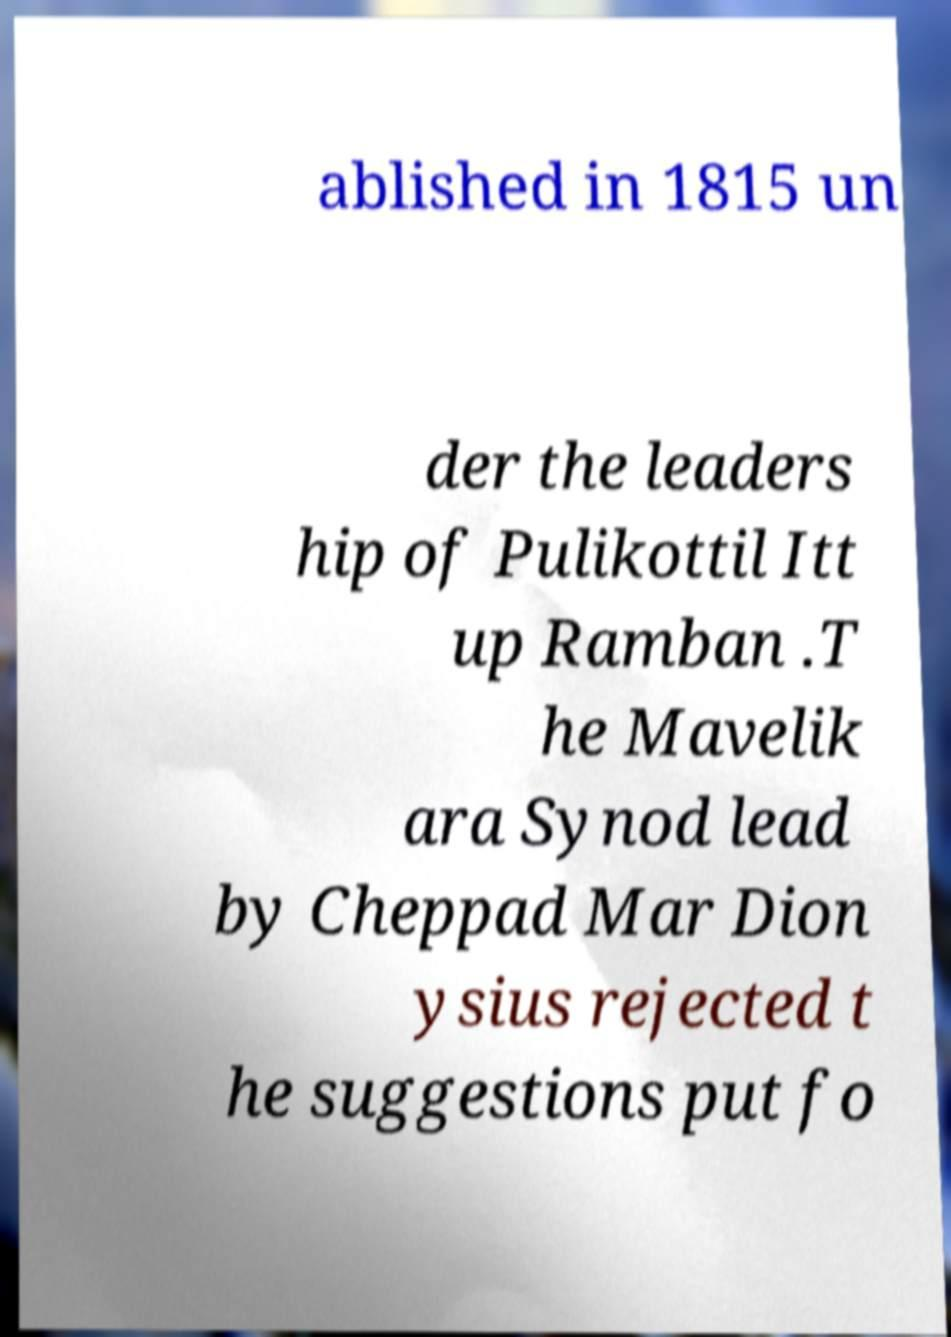There's text embedded in this image that I need extracted. Can you transcribe it verbatim? ablished in 1815 un der the leaders hip of Pulikottil Itt up Ramban .T he Mavelik ara Synod lead by Cheppad Mar Dion ysius rejected t he suggestions put fo 